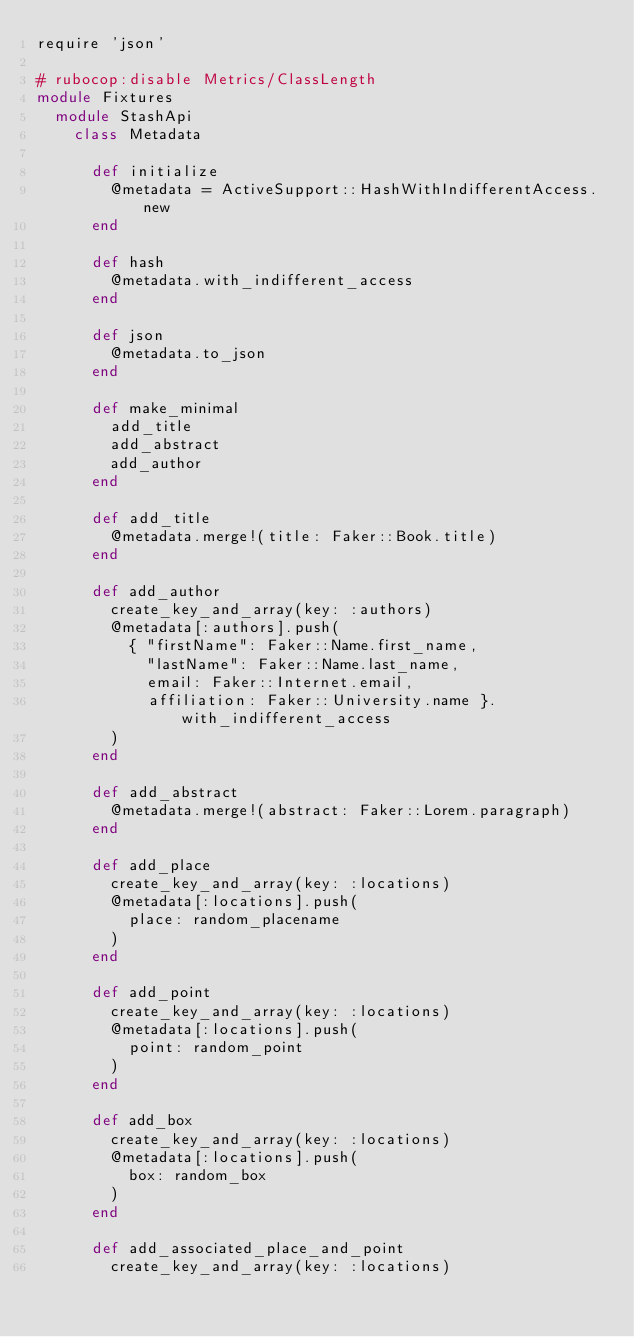<code> <loc_0><loc_0><loc_500><loc_500><_Ruby_>require 'json'

# rubocop:disable Metrics/ClassLength
module Fixtures
  module StashApi
    class Metadata

      def initialize
        @metadata = ActiveSupport::HashWithIndifferentAccess.new
      end

      def hash
        @metadata.with_indifferent_access
      end

      def json
        @metadata.to_json
      end

      def make_minimal
        add_title
        add_abstract
        add_author
      end

      def add_title
        @metadata.merge!(title: Faker::Book.title)
      end

      def add_author
        create_key_and_array(key: :authors)
        @metadata[:authors].push(
          { "firstName": Faker::Name.first_name,
            "lastName": Faker::Name.last_name,
            email: Faker::Internet.email,
            affiliation: Faker::University.name }.with_indifferent_access
        )
      end

      def add_abstract
        @metadata.merge!(abstract: Faker::Lorem.paragraph)
      end

      def add_place
        create_key_and_array(key: :locations)
        @metadata[:locations].push(
          place: random_placename
        )
      end

      def add_point
        create_key_and_array(key: :locations)
        @metadata[:locations].push(
          point: random_point
        )
      end

      def add_box
        create_key_and_array(key: :locations)
        @metadata[:locations].push(
          box: random_box
        )
      end

      def add_associated_place_and_point
        create_key_and_array(key: :locations)</code> 